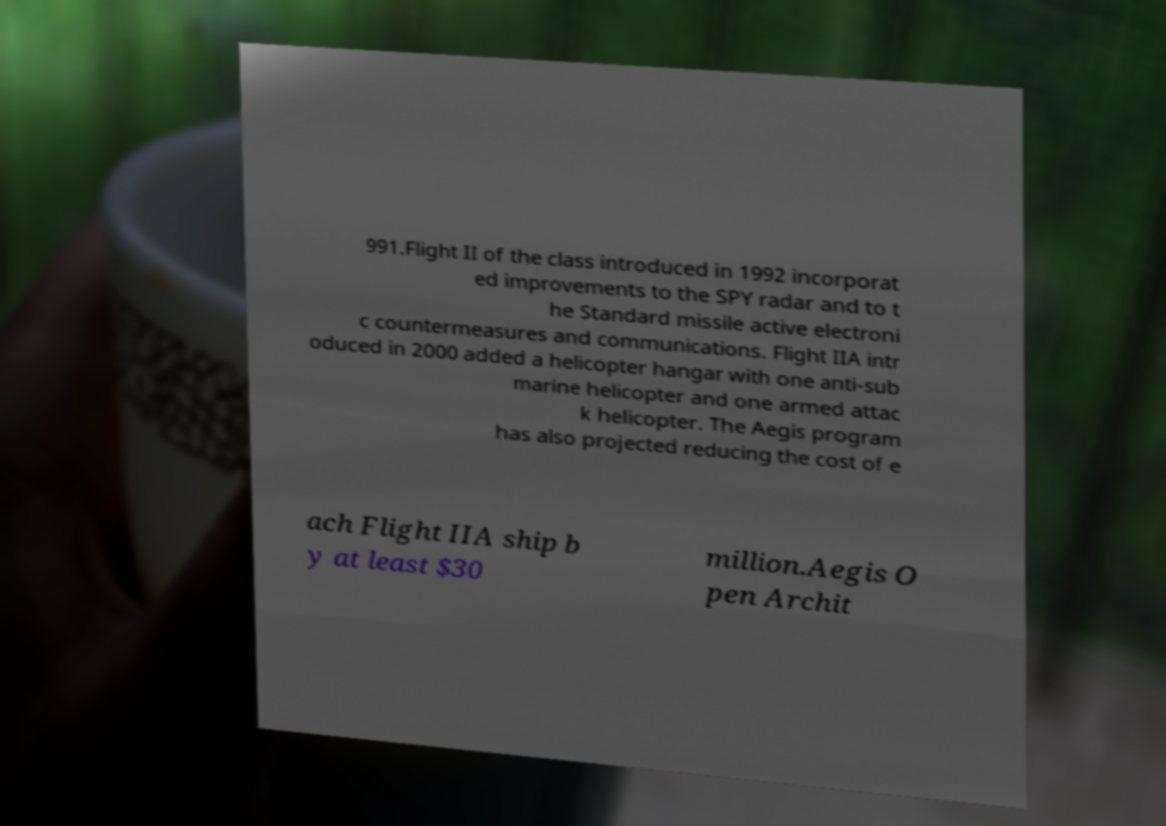There's text embedded in this image that I need extracted. Can you transcribe it verbatim? 991.Flight II of the class introduced in 1992 incorporat ed improvements to the SPY radar and to t he Standard missile active electroni c countermeasures and communications. Flight IIA intr oduced in 2000 added a helicopter hangar with one anti-sub marine helicopter and one armed attac k helicopter. The Aegis program has also projected reducing the cost of e ach Flight IIA ship b y at least $30 million.Aegis O pen Archit 